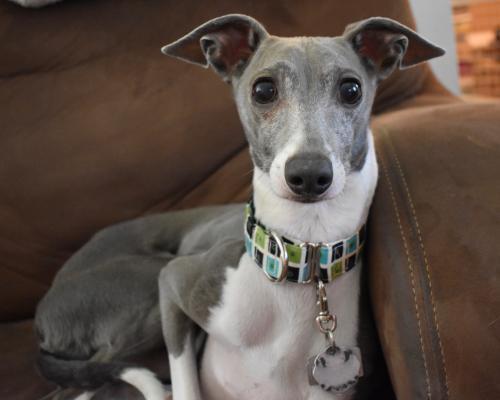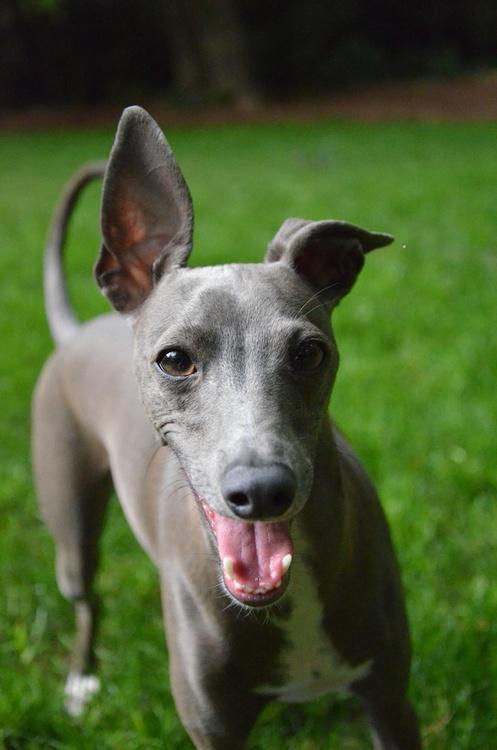The first image is the image on the left, the second image is the image on the right. Assess this claim about the two images: "The dog in the image on the right is standing in profile with its head turned toward the camera.". Correct or not? Answer yes or no. No. 